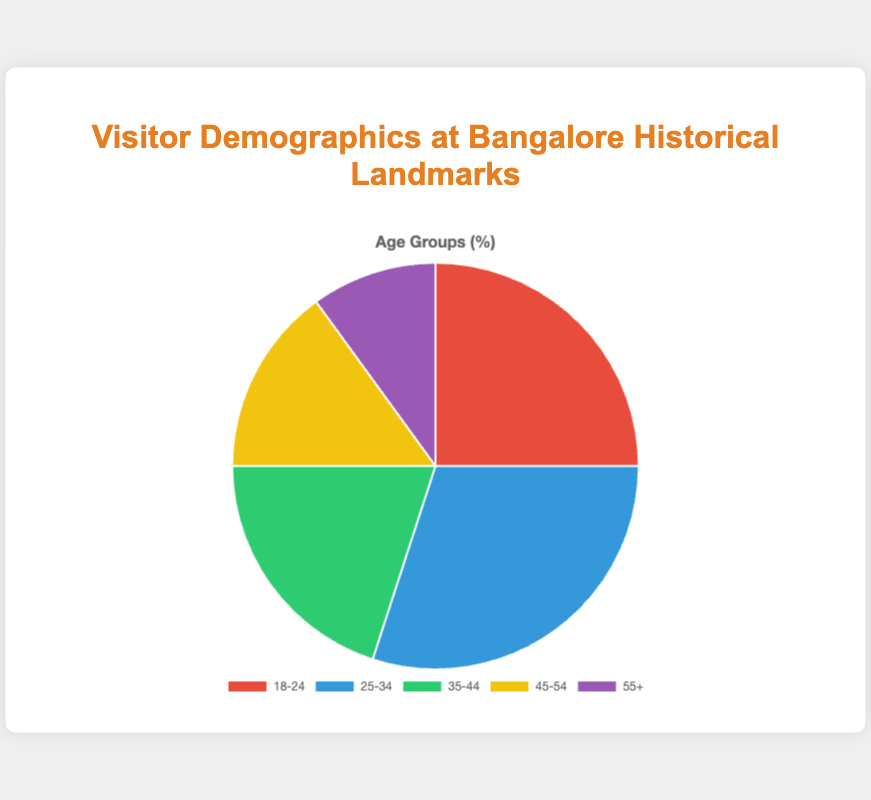Which age group has the highest percentage of visitors? The 25-34 age group has the highest percentage of visitors, as indicated by the largest slice in the pie chart.
Answer: 25-34 Which two age groups together make up 45% of all visitors? The 18-24 and 35-44 age groups together make up 45% (25% + 20%) of all visitors.
Answer: 18-24 and 35-44 By how much does the percentage of visitors aged 25-34 exceed those aged 55+? The percentage of visitors aged 25-34 is 30%, and those aged 55+ is 10%. The difference is 30% - 10% = 20%.
Answer: 20% What is the combined percentage of visitors aged 45-54 and 55+? The percentage of visitors aged 45-54 is 15%, and those aged 55+ is 10%. The combined percentage is 15% + 10% = 25%.
Answer: 25% Which age group has the smallest percentage of visitors, and what is the percentage? The 55+ age group has the smallest percentage of visitors, which is 10%.
Answer: 55+, 10% What percentage of visitors are aged between 18 and 34? The percentage of visitors aged 18-24 is 25%, and aged 25-34 is 30%. The combined percentage is 25% + 30% = 55%.
Answer: 55% Which age group's slice is depicted in blue? The blue slice represents the percentage of visitors aged 25-34.
Answer: 25-34 Which two age groups have the closest percentages of visitors, and what are their percentages? The 35-44 age group (20%) and the 45-54 age group (15%) have the closest percentages, with a difference of only 5%.
Answer: 35-44 and 45-54, 20% and 15% How much more is the percentage of visitors aged 18-24 compared to those aged 35-44? The percentage of visitors aged 18-24 is 25%, while for those aged 35-44 it is 20%. The difference is 25% - 20% = 5%.
Answer: 5% 